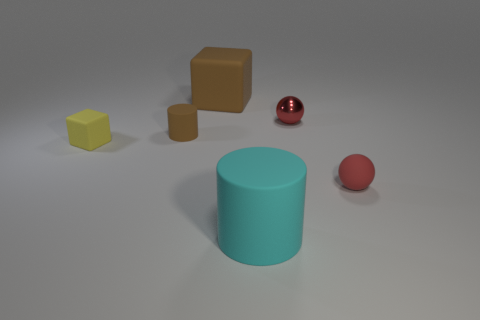Are there any matte things of the same color as the tiny shiny sphere?
Your answer should be very brief. Yes. Are there any tiny rubber cylinders right of the brown matte thing that is left of the large cube?
Offer a terse response. No. There is a cyan object that is the same size as the brown cube; what shape is it?
Offer a terse response. Cylinder. How many things are blocks that are in front of the red metal ball or big green metallic spheres?
Offer a very short reply. 1. How many other objects are there of the same material as the large cyan cylinder?
Keep it short and to the point. 4. What shape is the small rubber thing that is the same color as the large cube?
Give a very brief answer. Cylinder. How big is the cylinder behind the small red rubber ball?
Your answer should be compact. Small. There is a tiny brown thing that is made of the same material as the cyan thing; what is its shape?
Your response must be concise. Cylinder. Does the large brown object have the same material as the red thing that is behind the tiny yellow thing?
Offer a very short reply. No. Does the large matte thing that is in front of the yellow cube have the same shape as the yellow rubber thing?
Make the answer very short. No. 